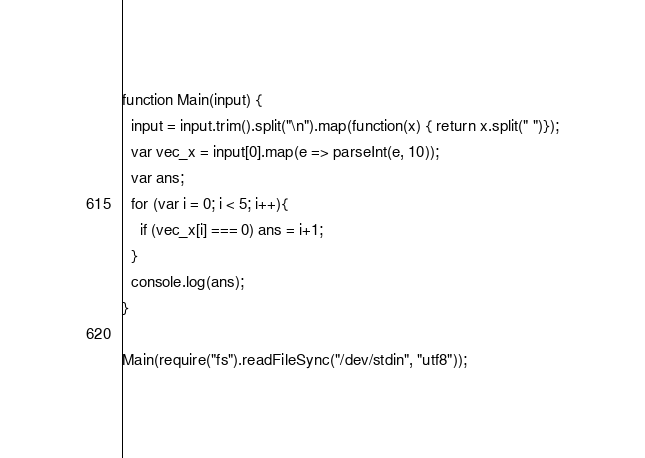Convert code to text. <code><loc_0><loc_0><loc_500><loc_500><_JavaScript_>function Main(input) {
  input = input.trim().split("\n").map(function(x) { return x.split(" ")});
  var vec_x = input[0].map(e => parseInt(e, 10));
  var ans;
  for (var i = 0; i < 5; i++){
    if (vec_x[i] === 0) ans = i+1;
  }
  console.log(ans);
}
 
Main(require("fs").readFileSync("/dev/stdin", "utf8"));
</code> 